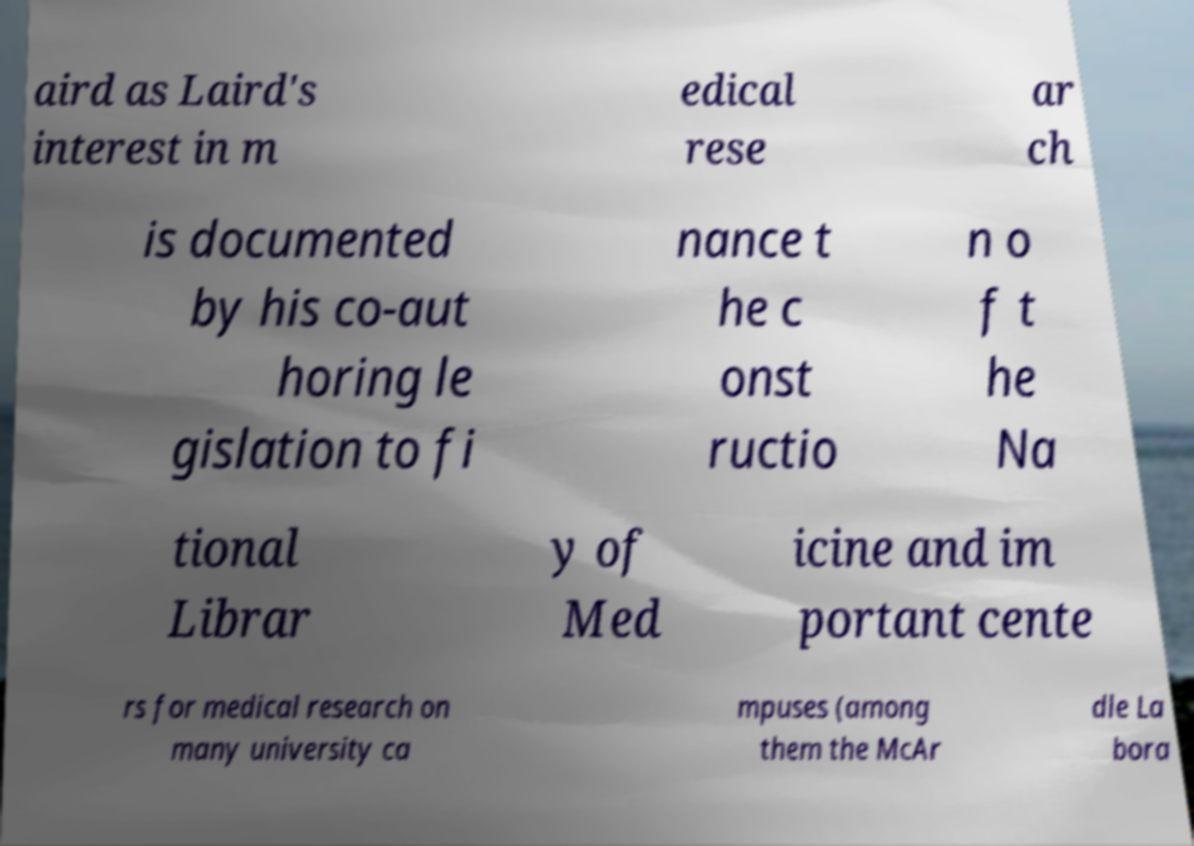Please identify and transcribe the text found in this image. aird as Laird's interest in m edical rese ar ch is documented by his co-aut horing le gislation to fi nance t he c onst ructio n o f t he Na tional Librar y of Med icine and im portant cente rs for medical research on many university ca mpuses (among them the McAr dle La bora 